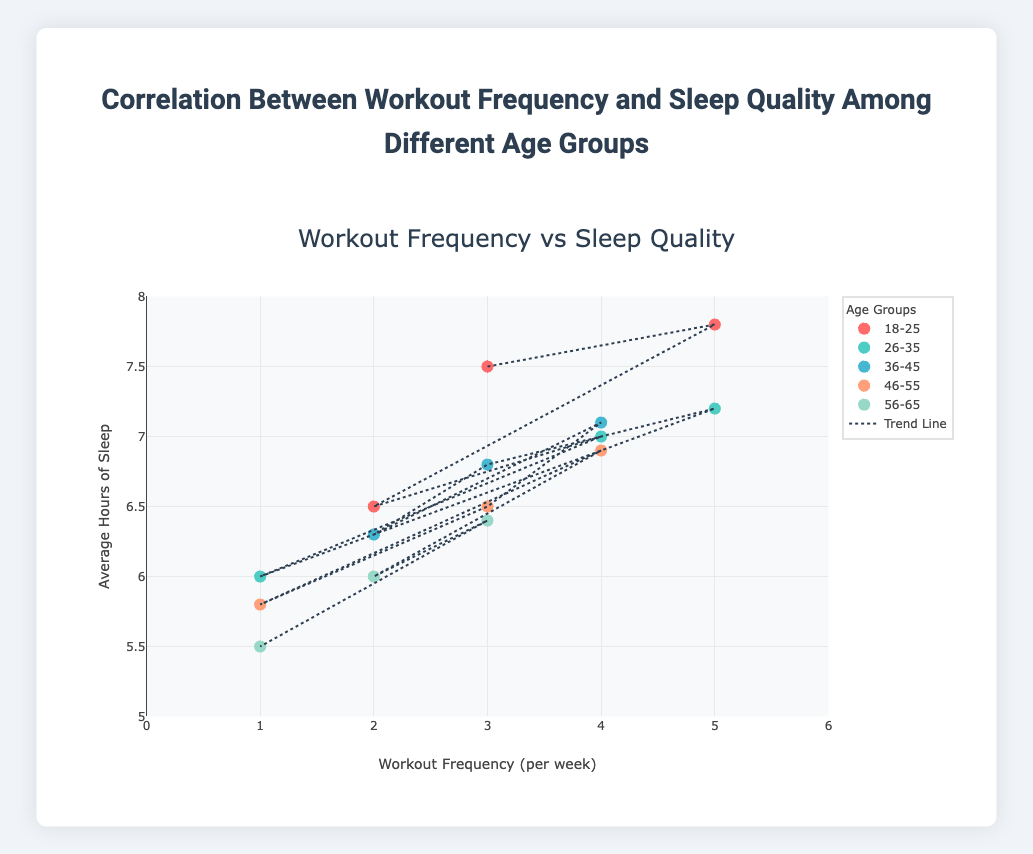What is the title of the plot? The title of the plot is found at the top, centered, and it reads 'Correlation Between Workout Frequency and Sleep Quality Among Different Age Groups.'
Answer: Correlation Between Workout Frequency and Sleep Quality Among Different Age Groups What is the range of the x-axis? The x-axis is labeled 'Workout Frequency (per week)' and has tick marks starting from 0 to 6 with a step of 1.
Answer: 0 to 6 Which age group has the highest average hours of sleep with 5 workouts per week? Locate the data points on the scatter plot for each age group that corresponds to 5 workouts per week. The point for the age group 18-25 is at 7.8 hours, while 26-35 also has 5 workouts but with 7.2 hours.
Answer: 18-25 Compare the average sleep hours for the age group 36-45 when working out 2 times per week and 4 times per week. How much more do they sleep when working out 4 times per week? From the plot, the average sleep hours for 36-45 with 2 workouts per week is 6.3, and with 4 workouts per week, it's 7.1. The difference is calculated as 7.1 - 6.3 = 0.8.
Answer: 0.8 hours What is the trend in sleep quality as workout frequency increases for the 26-35 age group? Looking at the 26-35 age group data points, the sleep quality increases from 6.0 hours with 1 workout, to 7.0 hours with 4 workouts, and 7.2 hours with 5 workouts, suggesting a positive trend.
Answer: Positive What is the general relationship between workout frequency and sleep quality shown by the trend line? The trend line, represented as a dashed line, generally moves upwards as it progresses from left to right, indicating a positive correlation between workout frequency and sleep quality across all data points.
Answer: Positive correlation How many distinct age groups are represented in the plot? The legend on the plot lists distinct categories, which correspond to the different age groups. By counting these groups, we see 5 distinct age groups are represented.
Answer: 5 What age group appears to have the least improvement in sleep quality with increased workout frequency? Examining the slope of the age group points, the 46-55 age group has a less pronounced increase in sleep quality when comparing workouts from least to most frequent workout points.
Answer: 46-55 For which workout frequency do we see the widest variation in sleep quality among different age groups? By comparing the vertical spread of data points for each workout frequency, the workout frequency of 3 per week shows the widest variation, ranging from about 6.4 to 7.5 hours.
Answer: 3 per week 